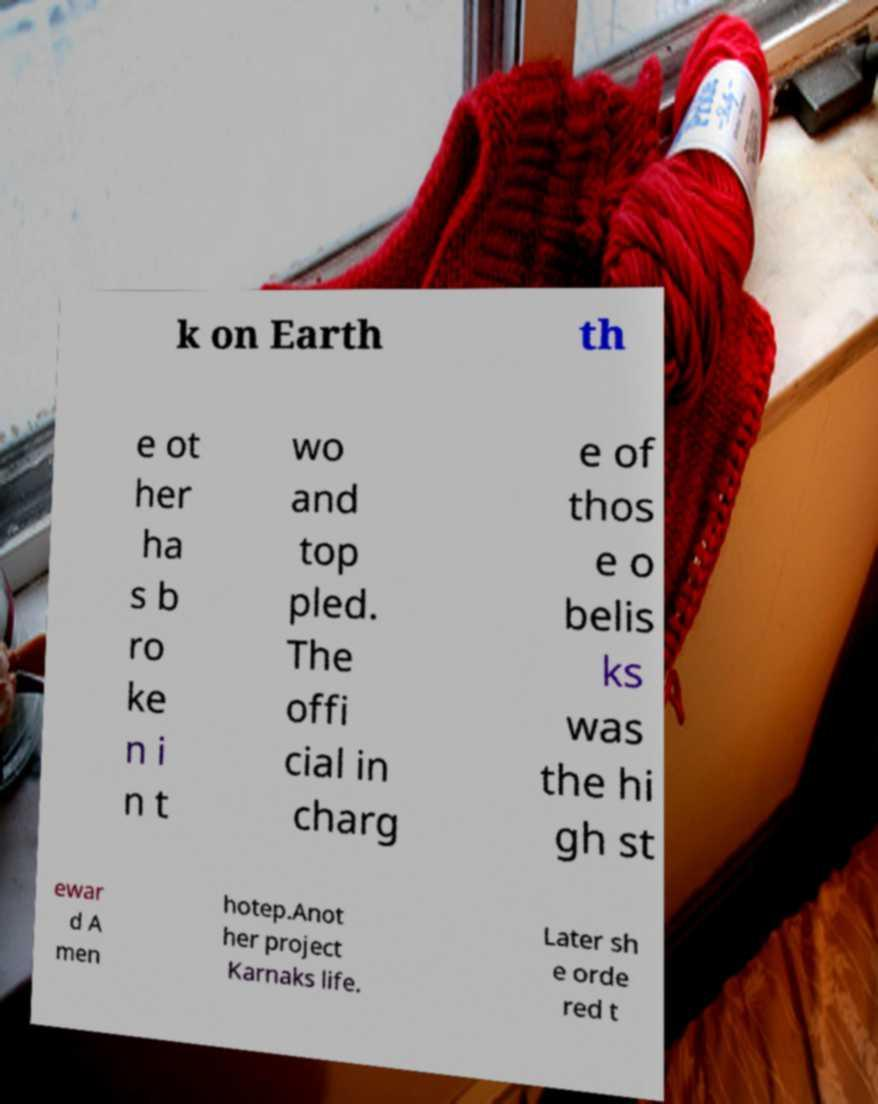Can you accurately transcribe the text from the provided image for me? k on Earth th e ot her ha s b ro ke n i n t wo and top pled. The offi cial in charg e of thos e o belis ks was the hi gh st ewar d A men hotep.Anot her project Karnaks life. Later sh e orde red t 